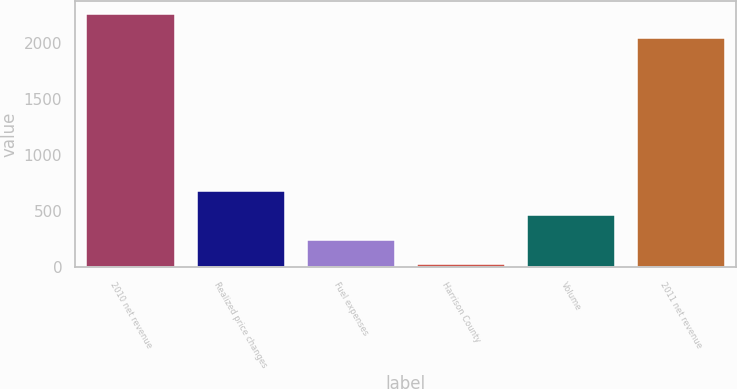Convert chart to OTSL. <chart><loc_0><loc_0><loc_500><loc_500><bar_chart><fcel>2010 net revenue<fcel>Realized price changes<fcel>Fuel expenses<fcel>Harrison County<fcel>Volume<fcel>2011 net revenue<nl><fcel>2261.3<fcel>678.9<fcel>244.3<fcel>27<fcel>461.6<fcel>2044<nl></chart> 